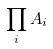<formula> <loc_0><loc_0><loc_500><loc_500>\prod _ { i } A _ { i }</formula> 